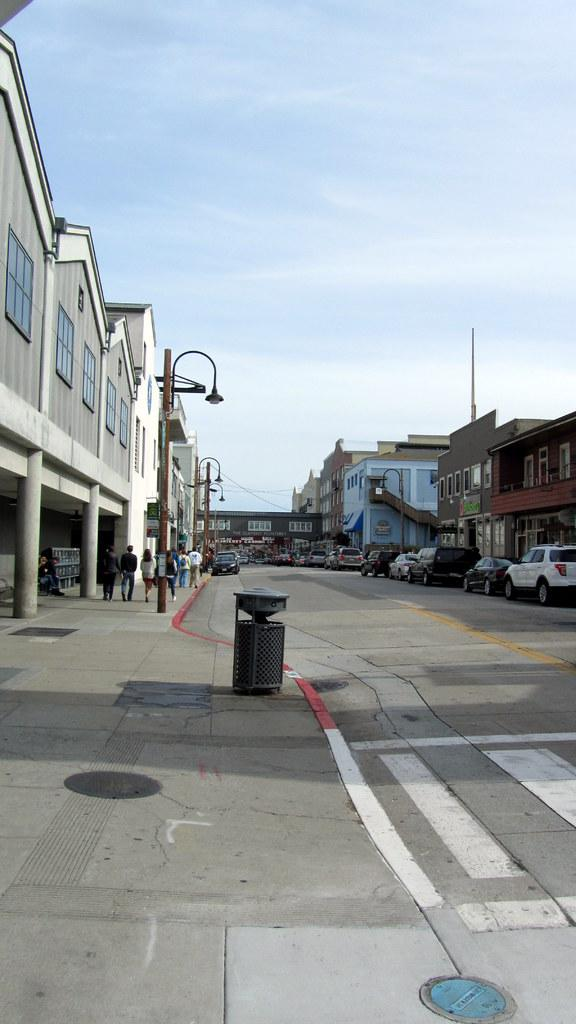Where was the image taken? The image was taken outside. What can be seen in the foreground of the image? There is a road in the foreground of the image. What structures are present on either side of the road? Buildings are present on either side of the road. What else can be seen on either side of the road? Poles and vehicles are present on either side of the road. What is visible at the top of the image? The sky is visible at the top of the image. What type of desk is visible in the image? There is no desk present in the image; it is taken outside and features a road, buildings, poles, vehicles, and the sky. Can you tell me how many donkeys are walking on the road in the image? There are no donkeys present in the image; it features a road, buildings, poles, vehicles, and the sky. 